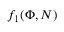<formula> <loc_0><loc_0><loc_500><loc_500>f _ { 1 } ( \Phi , N )</formula> 